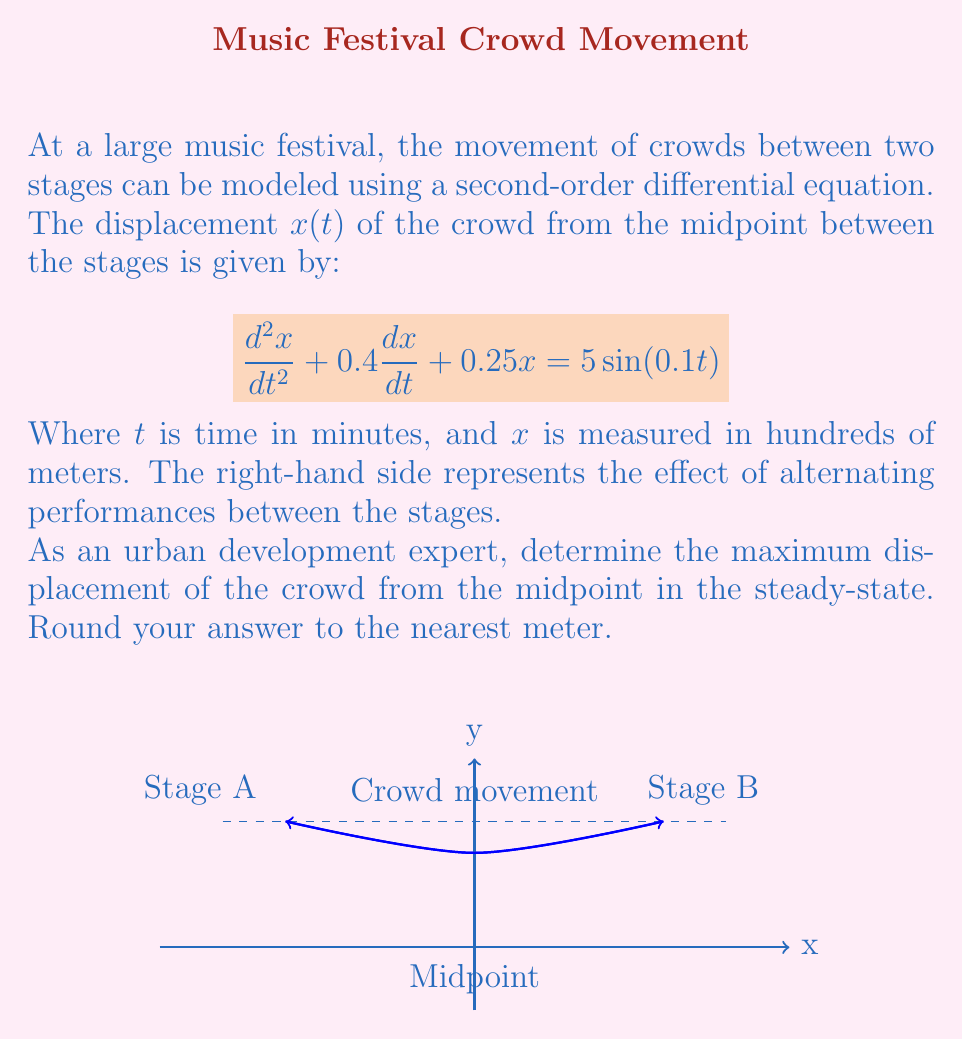Can you solve this math problem? To solve this problem, we'll follow these steps:

1) For a steady-state solution, we assume the form:
   $x(t) = A\sin(0.1t) + B\cos(0.1t)$

2) Substitute this into the original equation:
   $(-0.01A + 0.04B + 0.25A)\sin(0.1t) + (-0.01B - 0.04A + 0.25B)\cos(0.1t) = 5\sin(0.1t)$

3) Equating coefficients:
   $0.24A + 0.04B = 5$
   $-0.04A + 0.24B = 0$

4) Solve this system of equations:
   $A = 20.8333$
   $B = 3.4722$

5) The steady-state solution is:
   $x(t) = 20.8333\sin(0.1t) + 3.4722\cos(0.1t)$

6) To find the maximum displacement, we need to find the amplitude:
   $\text{Amplitude} = \sqrt{A^2 + B^2} = \sqrt{20.8333^2 + 3.4722^2} = 21.1382$

7) Convert to meters:
   $21.1382 * 100 = 2113.82$ meters

8) Round to the nearest meter:
   $2114$ meters
Answer: 2114 meters 